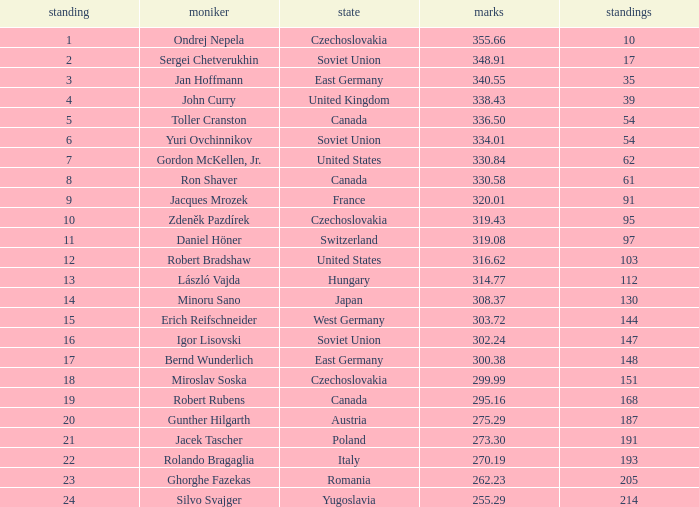Which Placings have a Nation of west germany, and Points larger than 303.72? None. 